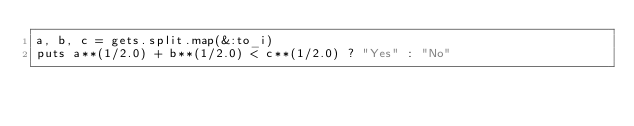<code> <loc_0><loc_0><loc_500><loc_500><_Ruby_>a, b, c = gets.split.map(&:to_i)
puts a**(1/2.0) + b**(1/2.0) < c**(1/2.0) ? "Yes" : "No"
</code> 